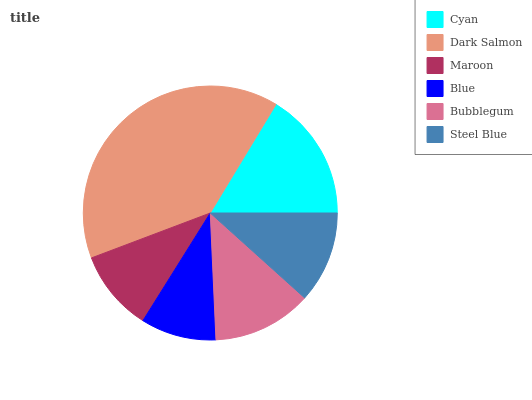Is Blue the minimum?
Answer yes or no. Yes. Is Dark Salmon the maximum?
Answer yes or no. Yes. Is Maroon the minimum?
Answer yes or no. No. Is Maroon the maximum?
Answer yes or no. No. Is Dark Salmon greater than Maroon?
Answer yes or no. Yes. Is Maroon less than Dark Salmon?
Answer yes or no. Yes. Is Maroon greater than Dark Salmon?
Answer yes or no. No. Is Dark Salmon less than Maroon?
Answer yes or no. No. Is Bubblegum the high median?
Answer yes or no. Yes. Is Steel Blue the low median?
Answer yes or no. Yes. Is Blue the high median?
Answer yes or no. No. Is Bubblegum the low median?
Answer yes or no. No. 